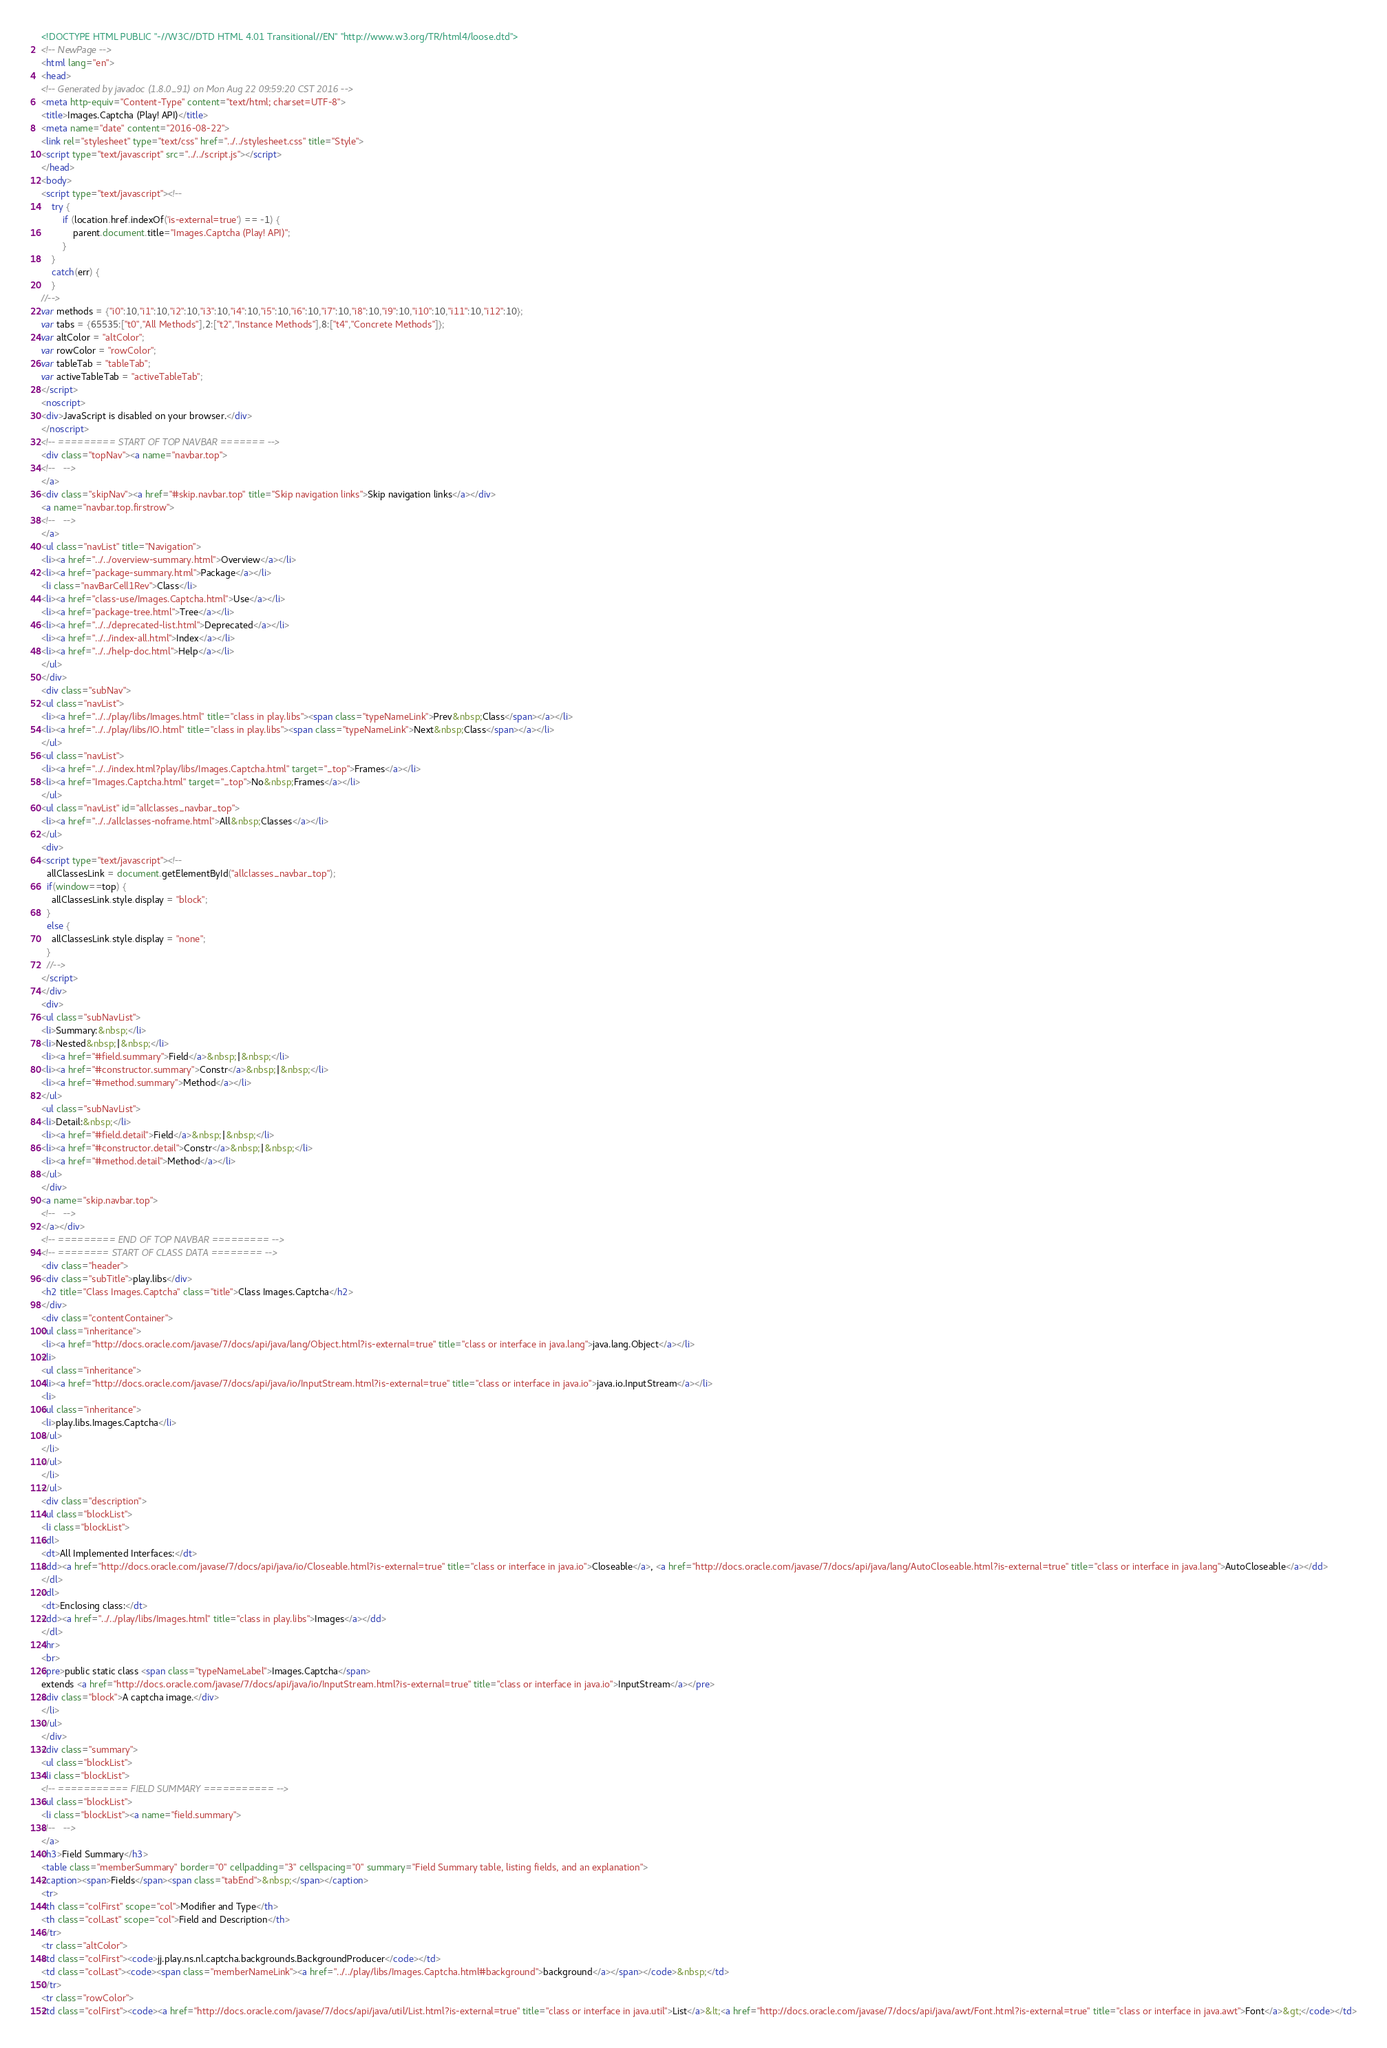Convert code to text. <code><loc_0><loc_0><loc_500><loc_500><_HTML_><!DOCTYPE HTML PUBLIC "-//W3C//DTD HTML 4.01 Transitional//EN" "http://www.w3.org/TR/html4/loose.dtd">
<!-- NewPage -->
<html lang="en">
<head>
<!-- Generated by javadoc (1.8.0_91) on Mon Aug 22 09:59:20 CST 2016 -->
<meta http-equiv="Content-Type" content="text/html; charset=UTF-8">
<title>Images.Captcha (Play! API)</title>
<meta name="date" content="2016-08-22">
<link rel="stylesheet" type="text/css" href="../../stylesheet.css" title="Style">
<script type="text/javascript" src="../../script.js"></script>
</head>
<body>
<script type="text/javascript"><!--
    try {
        if (location.href.indexOf('is-external=true') == -1) {
            parent.document.title="Images.Captcha (Play! API)";
        }
    }
    catch(err) {
    }
//-->
var methods = {"i0":10,"i1":10,"i2":10,"i3":10,"i4":10,"i5":10,"i6":10,"i7":10,"i8":10,"i9":10,"i10":10,"i11":10,"i12":10};
var tabs = {65535:["t0","All Methods"],2:["t2","Instance Methods"],8:["t4","Concrete Methods"]};
var altColor = "altColor";
var rowColor = "rowColor";
var tableTab = "tableTab";
var activeTableTab = "activeTableTab";
</script>
<noscript>
<div>JavaScript is disabled on your browser.</div>
</noscript>
<!-- ========= START OF TOP NAVBAR ======= -->
<div class="topNav"><a name="navbar.top">
<!--   -->
</a>
<div class="skipNav"><a href="#skip.navbar.top" title="Skip navigation links">Skip navigation links</a></div>
<a name="navbar.top.firstrow">
<!--   -->
</a>
<ul class="navList" title="Navigation">
<li><a href="../../overview-summary.html">Overview</a></li>
<li><a href="package-summary.html">Package</a></li>
<li class="navBarCell1Rev">Class</li>
<li><a href="class-use/Images.Captcha.html">Use</a></li>
<li><a href="package-tree.html">Tree</a></li>
<li><a href="../../deprecated-list.html">Deprecated</a></li>
<li><a href="../../index-all.html">Index</a></li>
<li><a href="../../help-doc.html">Help</a></li>
</ul>
</div>
<div class="subNav">
<ul class="navList">
<li><a href="../../play/libs/Images.html" title="class in play.libs"><span class="typeNameLink">Prev&nbsp;Class</span></a></li>
<li><a href="../../play/libs/IO.html" title="class in play.libs"><span class="typeNameLink">Next&nbsp;Class</span></a></li>
</ul>
<ul class="navList">
<li><a href="../../index.html?play/libs/Images.Captcha.html" target="_top">Frames</a></li>
<li><a href="Images.Captcha.html" target="_top">No&nbsp;Frames</a></li>
</ul>
<ul class="navList" id="allclasses_navbar_top">
<li><a href="../../allclasses-noframe.html">All&nbsp;Classes</a></li>
</ul>
<div>
<script type="text/javascript"><!--
  allClassesLink = document.getElementById("allclasses_navbar_top");
  if(window==top) {
    allClassesLink.style.display = "block";
  }
  else {
    allClassesLink.style.display = "none";
  }
  //-->
</script>
</div>
<div>
<ul class="subNavList">
<li>Summary:&nbsp;</li>
<li>Nested&nbsp;|&nbsp;</li>
<li><a href="#field.summary">Field</a>&nbsp;|&nbsp;</li>
<li><a href="#constructor.summary">Constr</a>&nbsp;|&nbsp;</li>
<li><a href="#method.summary">Method</a></li>
</ul>
<ul class="subNavList">
<li>Detail:&nbsp;</li>
<li><a href="#field.detail">Field</a>&nbsp;|&nbsp;</li>
<li><a href="#constructor.detail">Constr</a>&nbsp;|&nbsp;</li>
<li><a href="#method.detail">Method</a></li>
</ul>
</div>
<a name="skip.navbar.top">
<!--   -->
</a></div>
<!-- ========= END OF TOP NAVBAR ========= -->
<!-- ======== START OF CLASS DATA ======== -->
<div class="header">
<div class="subTitle">play.libs</div>
<h2 title="Class Images.Captcha" class="title">Class Images.Captcha</h2>
</div>
<div class="contentContainer">
<ul class="inheritance">
<li><a href="http://docs.oracle.com/javase/7/docs/api/java/lang/Object.html?is-external=true" title="class or interface in java.lang">java.lang.Object</a></li>
<li>
<ul class="inheritance">
<li><a href="http://docs.oracle.com/javase/7/docs/api/java/io/InputStream.html?is-external=true" title="class or interface in java.io">java.io.InputStream</a></li>
<li>
<ul class="inheritance">
<li>play.libs.Images.Captcha</li>
</ul>
</li>
</ul>
</li>
</ul>
<div class="description">
<ul class="blockList">
<li class="blockList">
<dl>
<dt>All Implemented Interfaces:</dt>
<dd><a href="http://docs.oracle.com/javase/7/docs/api/java/io/Closeable.html?is-external=true" title="class or interface in java.io">Closeable</a>, <a href="http://docs.oracle.com/javase/7/docs/api/java/lang/AutoCloseable.html?is-external=true" title="class or interface in java.lang">AutoCloseable</a></dd>
</dl>
<dl>
<dt>Enclosing class:</dt>
<dd><a href="../../play/libs/Images.html" title="class in play.libs">Images</a></dd>
</dl>
<hr>
<br>
<pre>public static class <span class="typeNameLabel">Images.Captcha</span>
extends <a href="http://docs.oracle.com/javase/7/docs/api/java/io/InputStream.html?is-external=true" title="class or interface in java.io">InputStream</a></pre>
<div class="block">A captcha image.</div>
</li>
</ul>
</div>
<div class="summary">
<ul class="blockList">
<li class="blockList">
<!-- =========== FIELD SUMMARY =========== -->
<ul class="blockList">
<li class="blockList"><a name="field.summary">
<!--   -->
</a>
<h3>Field Summary</h3>
<table class="memberSummary" border="0" cellpadding="3" cellspacing="0" summary="Field Summary table, listing fields, and an explanation">
<caption><span>Fields</span><span class="tabEnd">&nbsp;</span></caption>
<tr>
<th class="colFirst" scope="col">Modifier and Type</th>
<th class="colLast" scope="col">Field and Description</th>
</tr>
<tr class="altColor">
<td class="colFirst"><code>jj.play.ns.nl.captcha.backgrounds.BackgroundProducer</code></td>
<td class="colLast"><code><span class="memberNameLink"><a href="../../play/libs/Images.Captcha.html#background">background</a></span></code>&nbsp;</td>
</tr>
<tr class="rowColor">
<td class="colFirst"><code><a href="http://docs.oracle.com/javase/7/docs/api/java/util/List.html?is-external=true" title="class or interface in java.util">List</a>&lt;<a href="http://docs.oracle.com/javase/7/docs/api/java/awt/Font.html?is-external=true" title="class or interface in java.awt">Font</a>&gt;</code></td></code> 